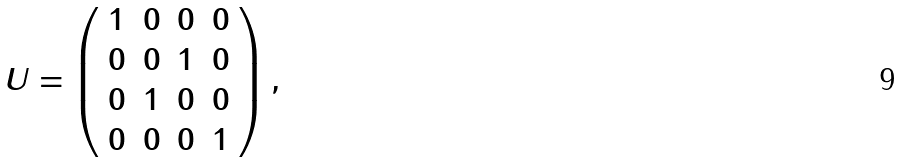<formula> <loc_0><loc_0><loc_500><loc_500>U = \left ( \begin{array} { c c c c } 1 & 0 & 0 & 0 \\ 0 & 0 & 1 & 0 \\ 0 & 1 & 0 & 0 \\ 0 & 0 & 0 & 1 \end{array} \right ) ,</formula> 